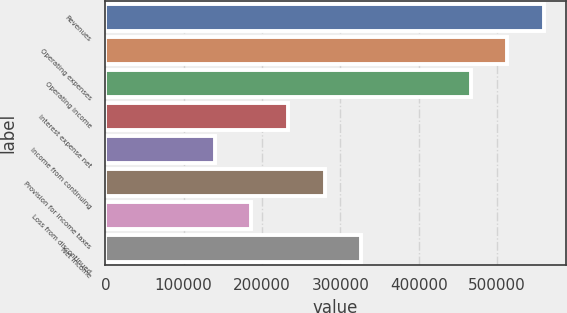Convert chart. <chart><loc_0><loc_0><loc_500><loc_500><bar_chart><fcel>Revenues<fcel>Operating expenses<fcel>Operating income<fcel>Interest expense net<fcel>Income from continuing<fcel>Provision for income taxes<fcel>Loss from discontinued<fcel>Net income<nl><fcel>559616<fcel>512982<fcel>466347<fcel>233174<fcel>139905<fcel>279808<fcel>186539<fcel>326443<nl></chart> 